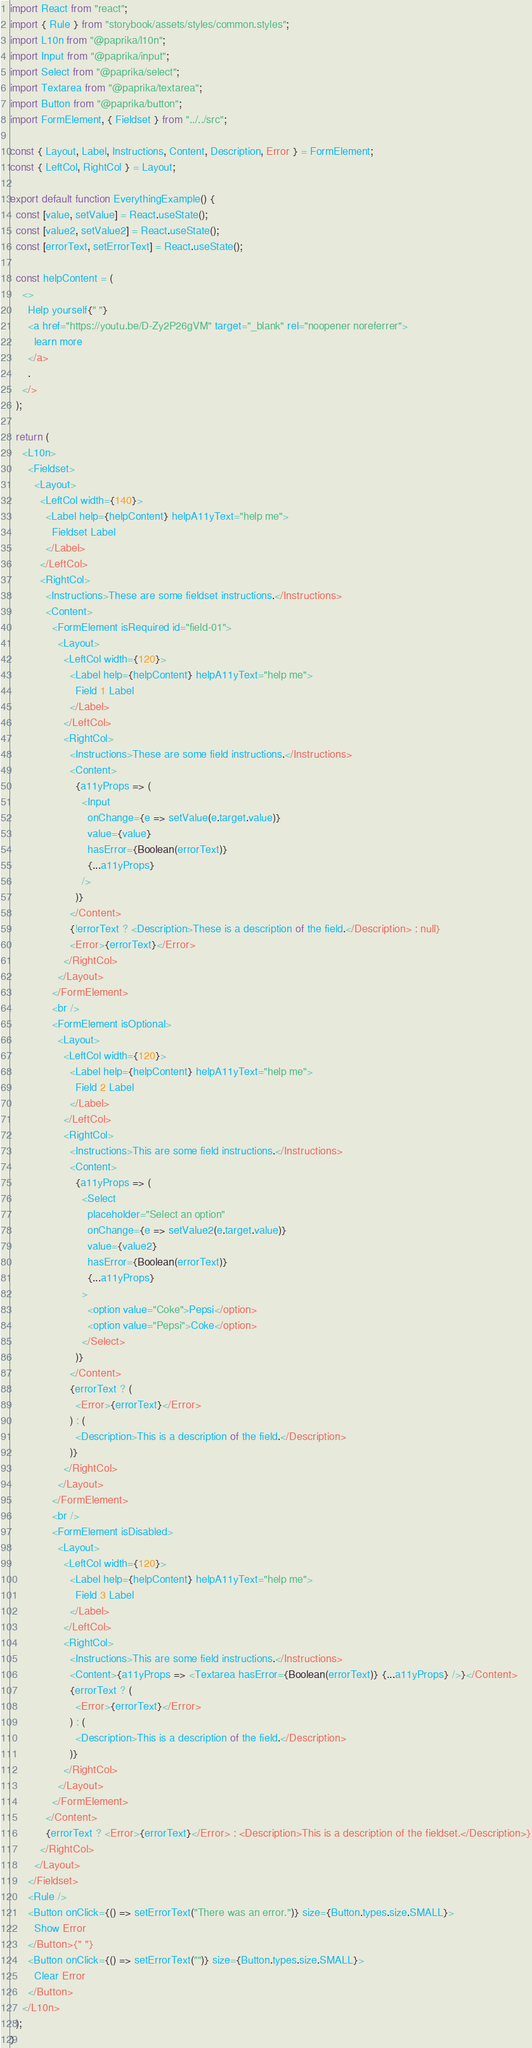Convert code to text. <code><loc_0><loc_0><loc_500><loc_500><_JavaScript_>import React from "react";
import { Rule } from "storybook/assets/styles/common.styles";
import L10n from "@paprika/l10n";
import Input from "@paprika/input";
import Select from "@paprika/select";
import Textarea from "@paprika/textarea";
import Button from "@paprika/button";
import FormElement, { Fieldset } from "../../src";

const { Layout, Label, Instructions, Content, Description, Error } = FormElement;
const { LeftCol, RightCol } = Layout;

export default function EverythingExample() {
  const [value, setValue] = React.useState();
  const [value2, setValue2] = React.useState();
  const [errorText, setErrorText] = React.useState();

  const helpContent = (
    <>
      Help yourself{" "}
      <a href="https://youtu.be/D-Zy2P26gVM" target="_blank" rel="noopener noreferrer">
        learn more
      </a>
      .
    </>
  );

  return (
    <L10n>
      <Fieldset>
        <Layout>
          <LeftCol width={140}>
            <Label help={helpContent} helpA11yText="help me">
              Fieldset Label
            </Label>
          </LeftCol>
          <RightCol>
            <Instructions>These are some fieldset instructions.</Instructions>
            <Content>
              <FormElement isRequired id="field-01">
                <Layout>
                  <LeftCol width={120}>
                    <Label help={helpContent} helpA11yText="help me">
                      Field 1 Label
                    </Label>
                  </LeftCol>
                  <RightCol>
                    <Instructions>These are some field instructions.</Instructions>
                    <Content>
                      {a11yProps => (
                        <Input
                          onChange={e => setValue(e.target.value)}
                          value={value}
                          hasError={Boolean(errorText)}
                          {...a11yProps}
                        />
                      )}
                    </Content>
                    {!errorText ? <Description>These is a description of the field.</Description> : null}
                    <Error>{errorText}</Error>
                  </RightCol>
                </Layout>
              </FormElement>
              <br />
              <FormElement isOptional>
                <Layout>
                  <LeftCol width={120}>
                    <Label help={helpContent} helpA11yText="help me">
                      Field 2 Label
                    </Label>
                  </LeftCol>
                  <RightCol>
                    <Instructions>This are some field instructions.</Instructions>
                    <Content>
                      {a11yProps => (
                        <Select
                          placeholder="Select an option"
                          onChange={e => setValue2(e.target.value)}
                          value={value2}
                          hasError={Boolean(errorText)}
                          {...a11yProps}
                        >
                          <option value="Coke">Pepsi</option>
                          <option value="Pepsi">Coke</option>
                        </Select>
                      )}
                    </Content>
                    {errorText ? (
                      <Error>{errorText}</Error>
                    ) : (
                      <Description>This is a description of the field.</Description>
                    )}
                  </RightCol>
                </Layout>
              </FormElement>
              <br />
              <FormElement isDisabled>
                <Layout>
                  <LeftCol width={120}>
                    <Label help={helpContent} helpA11yText="help me">
                      Field 3 Label
                    </Label>
                  </LeftCol>
                  <RightCol>
                    <Instructions>This are some field instructions.</Instructions>
                    <Content>{a11yProps => <Textarea hasError={Boolean(errorText)} {...a11yProps} />}</Content>
                    {errorText ? (
                      <Error>{errorText}</Error>
                    ) : (
                      <Description>This is a description of the field.</Description>
                    )}
                  </RightCol>
                </Layout>
              </FormElement>
            </Content>
            {errorText ? <Error>{errorText}</Error> : <Description>This is a description of the fieldset.</Description>}
          </RightCol>
        </Layout>
      </Fieldset>
      <Rule />
      <Button onClick={() => setErrorText("There was an error.")} size={Button.types.size.SMALL}>
        Show Error
      </Button>{" "}
      <Button onClick={() => setErrorText("")} size={Button.types.size.SMALL}>
        Clear Error
      </Button>
    </L10n>
  );
}
</code> 